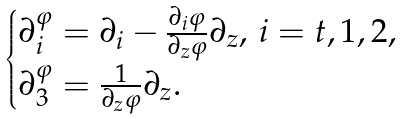<formula> <loc_0><loc_0><loc_500><loc_500>\begin{cases} \partial { _ { i } ^ { \varphi } } = \partial _ { i } - \frac { \partial _ { i } \varphi } { \partial _ { z } \varphi } \partial _ { z } , \, i = t , 1 , 2 , \\ \partial { _ { 3 } ^ { \varphi } } = \frac { 1 } { \partial _ { z } \varphi } \partial _ { z } . \end{cases}</formula> 